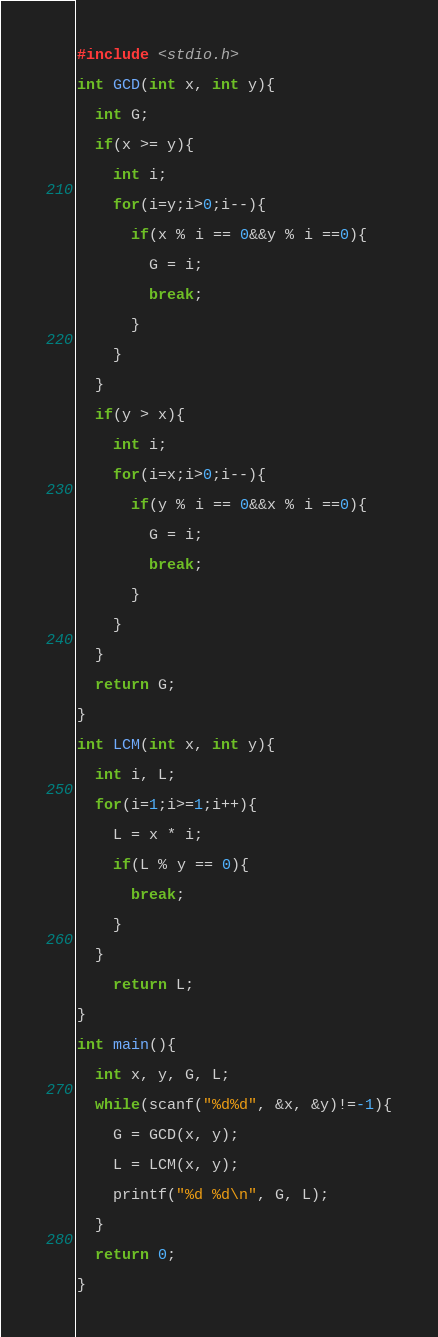Convert code to text. <code><loc_0><loc_0><loc_500><loc_500><_C_>#include <stdio.h>

int GCD(int x, int y){

  int G;

  if(x >= y){

    int i;

    for(i=y;i>0;i--){

      if(x % i == 0&&y % i ==0){

        G = i;

        break;

      }

    }

  }

  if(y > x){

    int i;

    for(i=x;i>0;i--){

      if(y % i == 0&&x % i ==0){

        G = i;

        break;

      }

    }

  }

  return G;

}

int LCM(int x, int y){

  int i, L;

  for(i=1;i>=1;i++){

    L = x * i;

    if(L % y == 0){

      break;

    }

  }

    return L;

}

int main(){

  int x, y, G, L;

  while(scanf("%d%d", &x, &y)!=-1){

    G = GCD(x, y);

    L = LCM(x, y);

    printf("%d %d\n", G, L);

  }

  return 0;

}</code> 